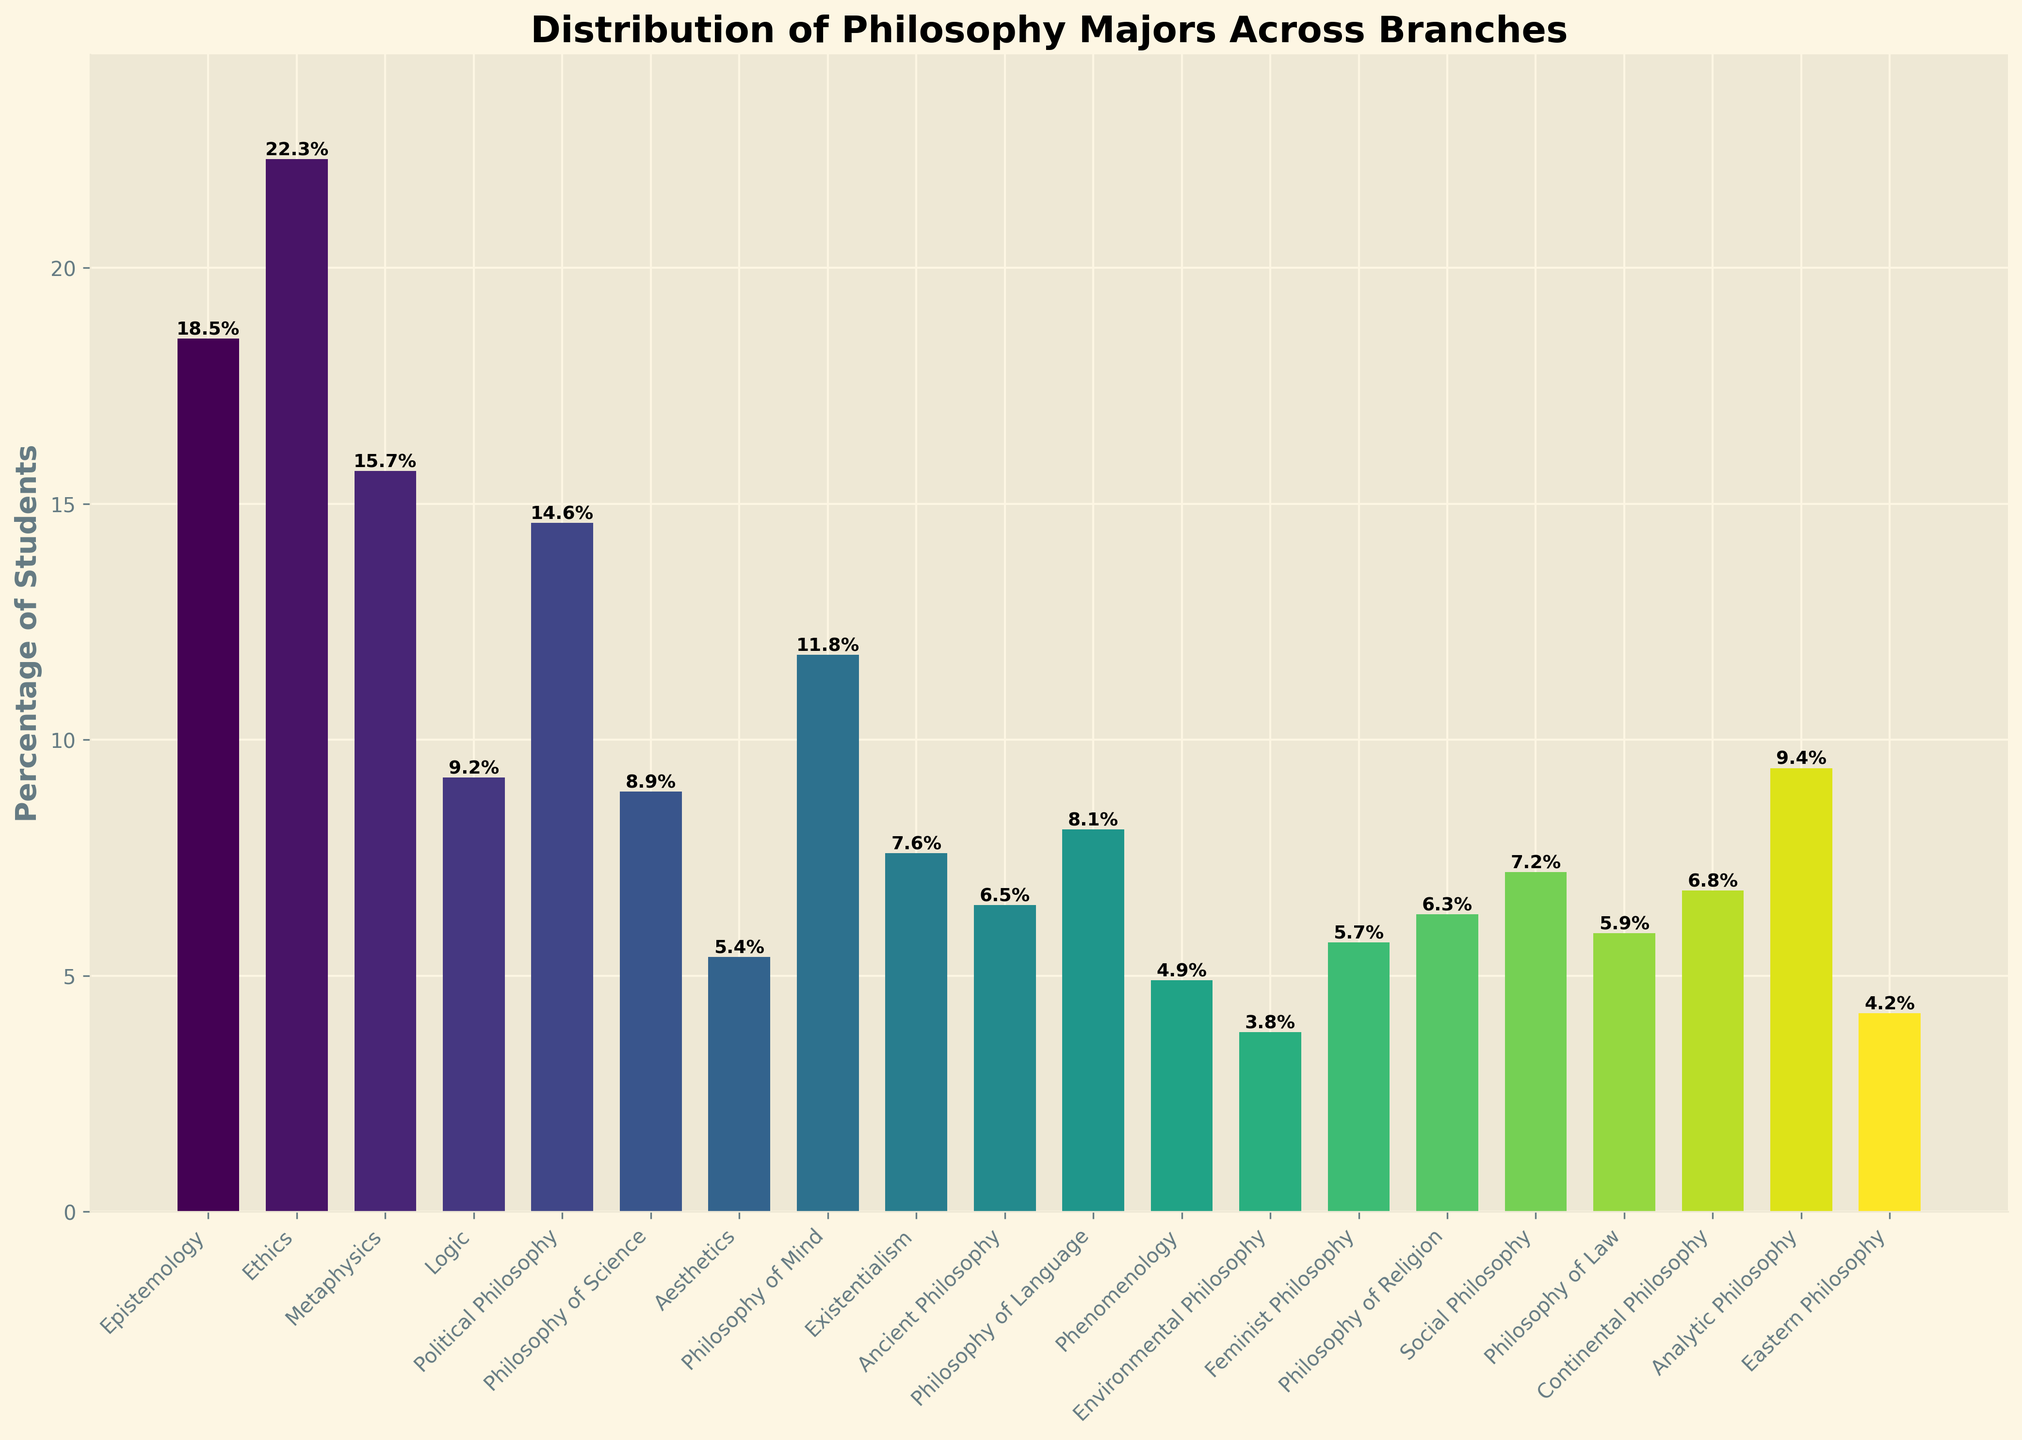What's the branch with the highest percentage of students? The bar corresponding to Ethics has the highest height among all branches, indicating that Ethics has the highest percentage of students.
Answer: Ethics Which branch has a slightly higher percentage of students: Philosophy of Science or Existentialism? The bar for Philosophy of Science is slightly taller than the bar for Existentialism. Philosophy of Science has 8.9% and Existentialism has 7.6%.
Answer: Philosophy of Science What percentage of students are majoring in branches below 10%? Sum the percentages of all branches with less than 10%. These branches are: Logic (9.2), Philosophy of Science (8.9), Aesthetics (5.4), Existentialism (7.6), Ancient Philosophy (6.5), Philosophy of Language (8.1), Phenomenology (4.9), Environmental Philosophy (3.8), Feminist Philosophy (5.7), Philosophy of Religion (6.3), Social Philosophy (7.2), Philosophy of Law (5.9), Continental Philosophy (6.8), Analytic Philosophy (9.4), Eastern Philosophy (4.2). The sum is 110.9%.
Answer: 110.9% If you sum the percentages for Epistemology, Metaphysics, and Political Philosophy, what value do you get? The percentages for Epistemology, Metaphysics, and Political Philosophy are 18.5%, 15.7%, and 14.6% respectively. Summing these values gives 18.5 + 15.7 + 14.6 = 48.8%.
Answer: 48.8% Are there more students majoring in Logic than in Continental Philosophy? Compare the heights of the bars for Logic and Continental Philosophy. Logic has 9.2% and Continental Philosophy has 6.8%. So, there are more students majoring in Logic.
Answer: Yes Which two branches have the closest percentages of students majoring in them? Look for bars with similar heights. Ancient Philosophy and Continental Philosophy are closest with 6.5% and 6.8% respectively.
Answer: Ancient Philosophy and Continental Philosophy Is the percentage of students in Aesthetics higher than in Phenomenology? Compare the heights of the bars for Aesthetics and Phenomenology. Aesthetics is at 5.4% and Phenomenology is at 4.9%, so Aesthetics is higher.
Answer: Yes How much higher is the percentage of students majoring in Ethics compared to Political Philosophy? Ethics has 22.3% and Political Philosophy has 14.6%. The difference is 22.3 - 14.6 = 7.7%.
Answer: 7.7% What is the median percentage among all branches? Arrange the percentages in ascending order: 3.8, 4.2, 4.9, 5.4, 5.7, 5.9, 6.3, 6.5, 6.8, 7.2, 7.6, 8.1, 8.9, 9.2, 9.4, 11.8, 14.6, 15.7, 18.5, 22.3. With 20 values, the median is the average of the 10th and 11th values: (7.2 + 7.6)/2 = 7.4%.
Answer: 7.4% Which branch has the lowest percentage of students majoring in it? The shortest bar corresponds to Environmental Philosophy, which has a percentage of 3.8%.
Answer: Environmental Philosophy 